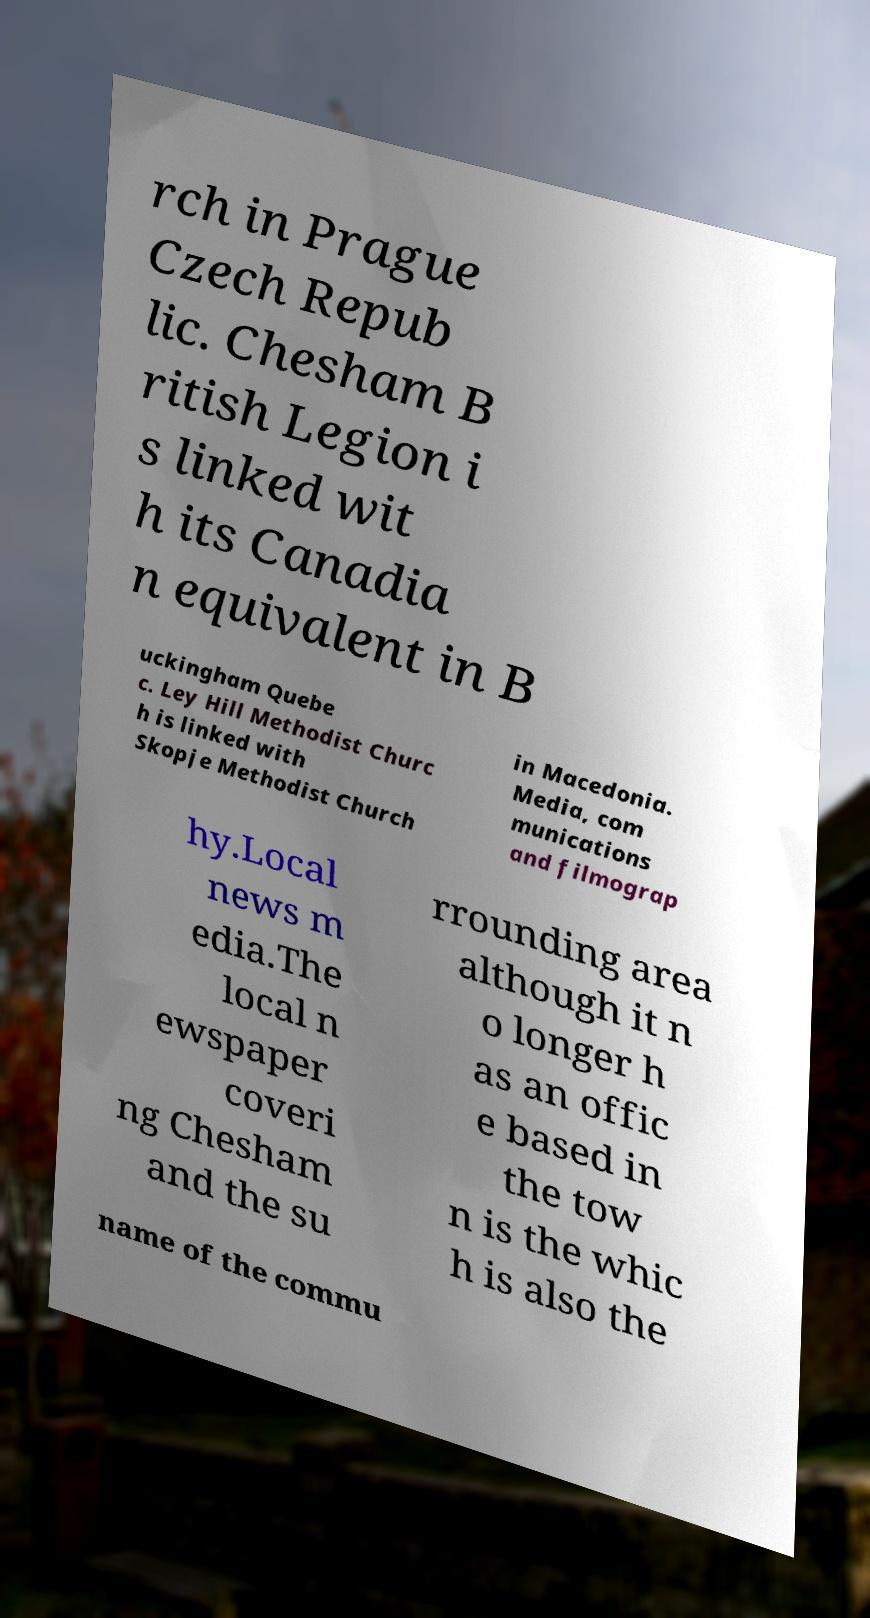There's text embedded in this image that I need extracted. Can you transcribe it verbatim? rch in Prague Czech Repub lic. Chesham B ritish Legion i s linked wit h its Canadia n equivalent in B uckingham Quebe c. Ley Hill Methodist Churc h is linked with Skopje Methodist Church in Macedonia. Media, com munications and filmograp hy.Local news m edia.The local n ewspaper coveri ng Chesham and the su rrounding area although it n o longer h as an offic e based in the tow n is the whic h is also the name of the commu 